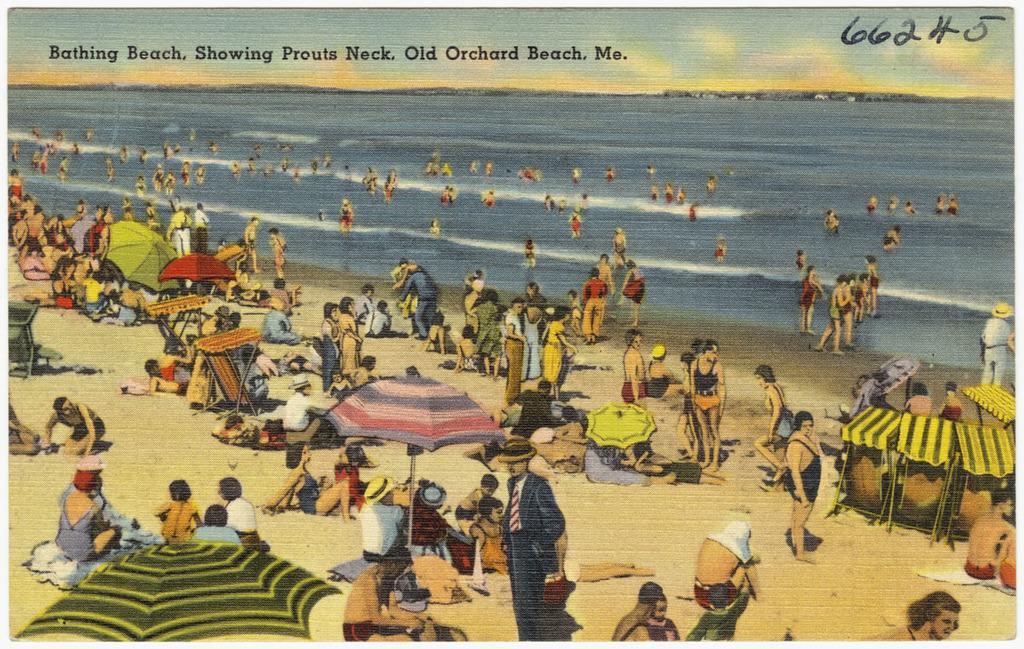Describe this image in one or two sentences. This is the picture of a beach in which there are some people and also we can see some people laying and some other people sitting under the umbrellas and tents on the sand floor. 